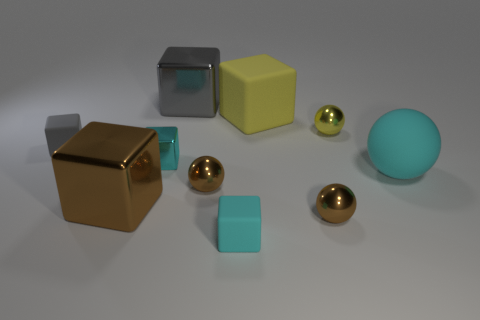Subtract all tiny matte cubes. How many cubes are left? 4 Subtract all cyan spheres. How many spheres are left? 3 Subtract 1 blocks. How many blocks are left? 5 Subtract 0 red cylinders. How many objects are left? 10 Subtract all blocks. How many objects are left? 4 Subtract all red cubes. Subtract all blue cylinders. How many cubes are left? 6 Subtract all blue spheres. How many brown cubes are left? 1 Subtract all tiny gray rubber cubes. Subtract all small yellow shiny balls. How many objects are left? 8 Add 7 small gray objects. How many small gray objects are left? 8 Add 1 small green metal objects. How many small green metal objects exist? 1 